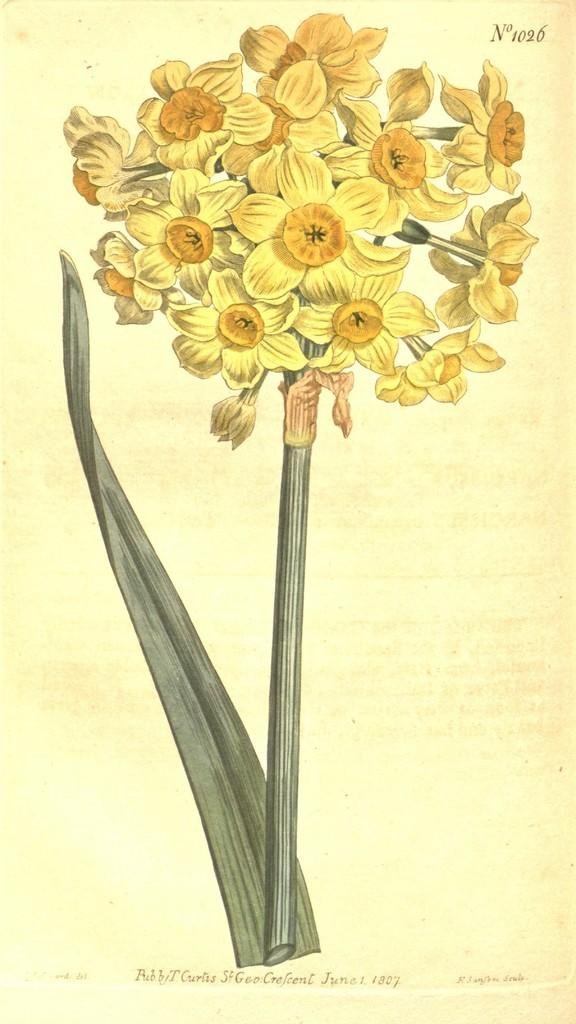What is located in the foreground of the image? There is a bunch of flowers in the foreground of the image. Can you describe any additional features of the flowers? Yes, there is a leaf associated with the flowers in the foreground. What is the color or tone of the background in the image? The background of the image is creamy. What type of cat can be seen playing with a rat in the scene depicted in the image? There is no cat or rat present in the image; it features a bunch of flowers with a leaf in the foreground and a creamy background. 